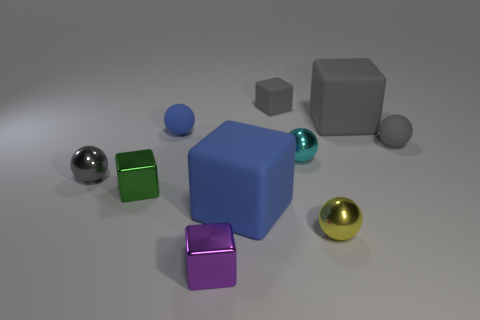Subtract all cyan spheres. How many spheres are left? 4 Subtract all small yellow metal balls. How many balls are left? 4 Subtract 2 balls. How many balls are left? 3 Subtract all brown spheres. Subtract all cyan blocks. How many spheres are left? 5 Add 3 tiny cyan cubes. How many tiny cyan cubes exist? 3 Subtract 1 gray cubes. How many objects are left? 9 Subtract all yellow spheres. Subtract all large things. How many objects are left? 7 Add 3 gray shiny objects. How many gray shiny objects are left? 4 